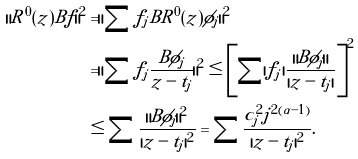<formula> <loc_0><loc_0><loc_500><loc_500>\| R ^ { 0 } ( z ) B f \| ^ { 2 } & = \| \sum f _ { j } B R ^ { 0 } ( z ) \phi _ { j } \| ^ { 2 } \\ & = \| \sum f _ { j } \frac { B \phi _ { j } } { z - t _ { j } } \| ^ { 2 } \leq \left [ \sum | f _ { j } | \frac { \| B \phi _ { j } \| } { | z - t _ { j } | } \right ] ^ { 2 } \\ & \leq \sum \frac { \| B \phi _ { j } \| ^ { 2 } } { | z - t _ { j } | ^ { 2 } } = \sum \frac { c _ { j } ^ { 2 } j ^ { 2 ( \alpha - 1 ) } } { | z - t _ { j } | ^ { 2 } } .</formula> 